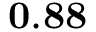Convert formula to latex. <formula><loc_0><loc_0><loc_500><loc_500>0 . 8 8</formula> 